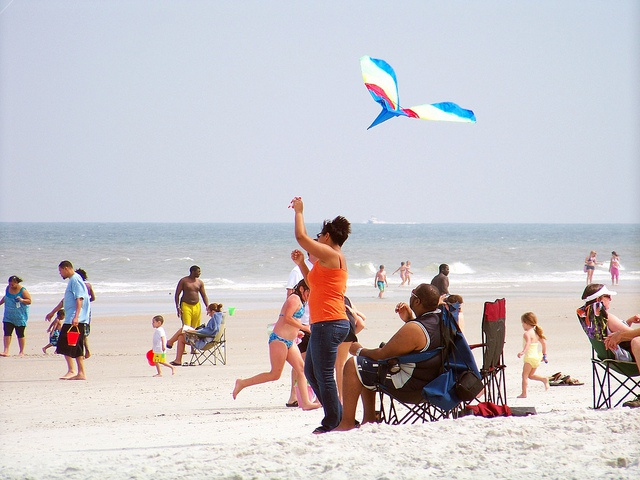Describe the objects in this image and their specific colors. I can see people in lavender, black, red, and brown tones, chair in lavender, black, navy, white, and maroon tones, people in lavender, maroon, black, brown, and lightgray tones, people in lavender and salmon tones, and kite in lavender, white, lightblue, and blue tones in this image. 